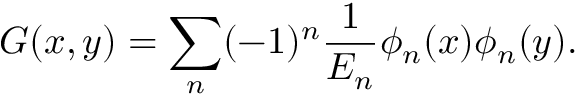<formula> <loc_0><loc_0><loc_500><loc_500>G ( x , y ) = \sum _ { n } ( - 1 ) ^ { n } \frac { 1 } { E _ { n } } \phi _ { n } ( x ) \phi _ { n } ( y ) .</formula> 